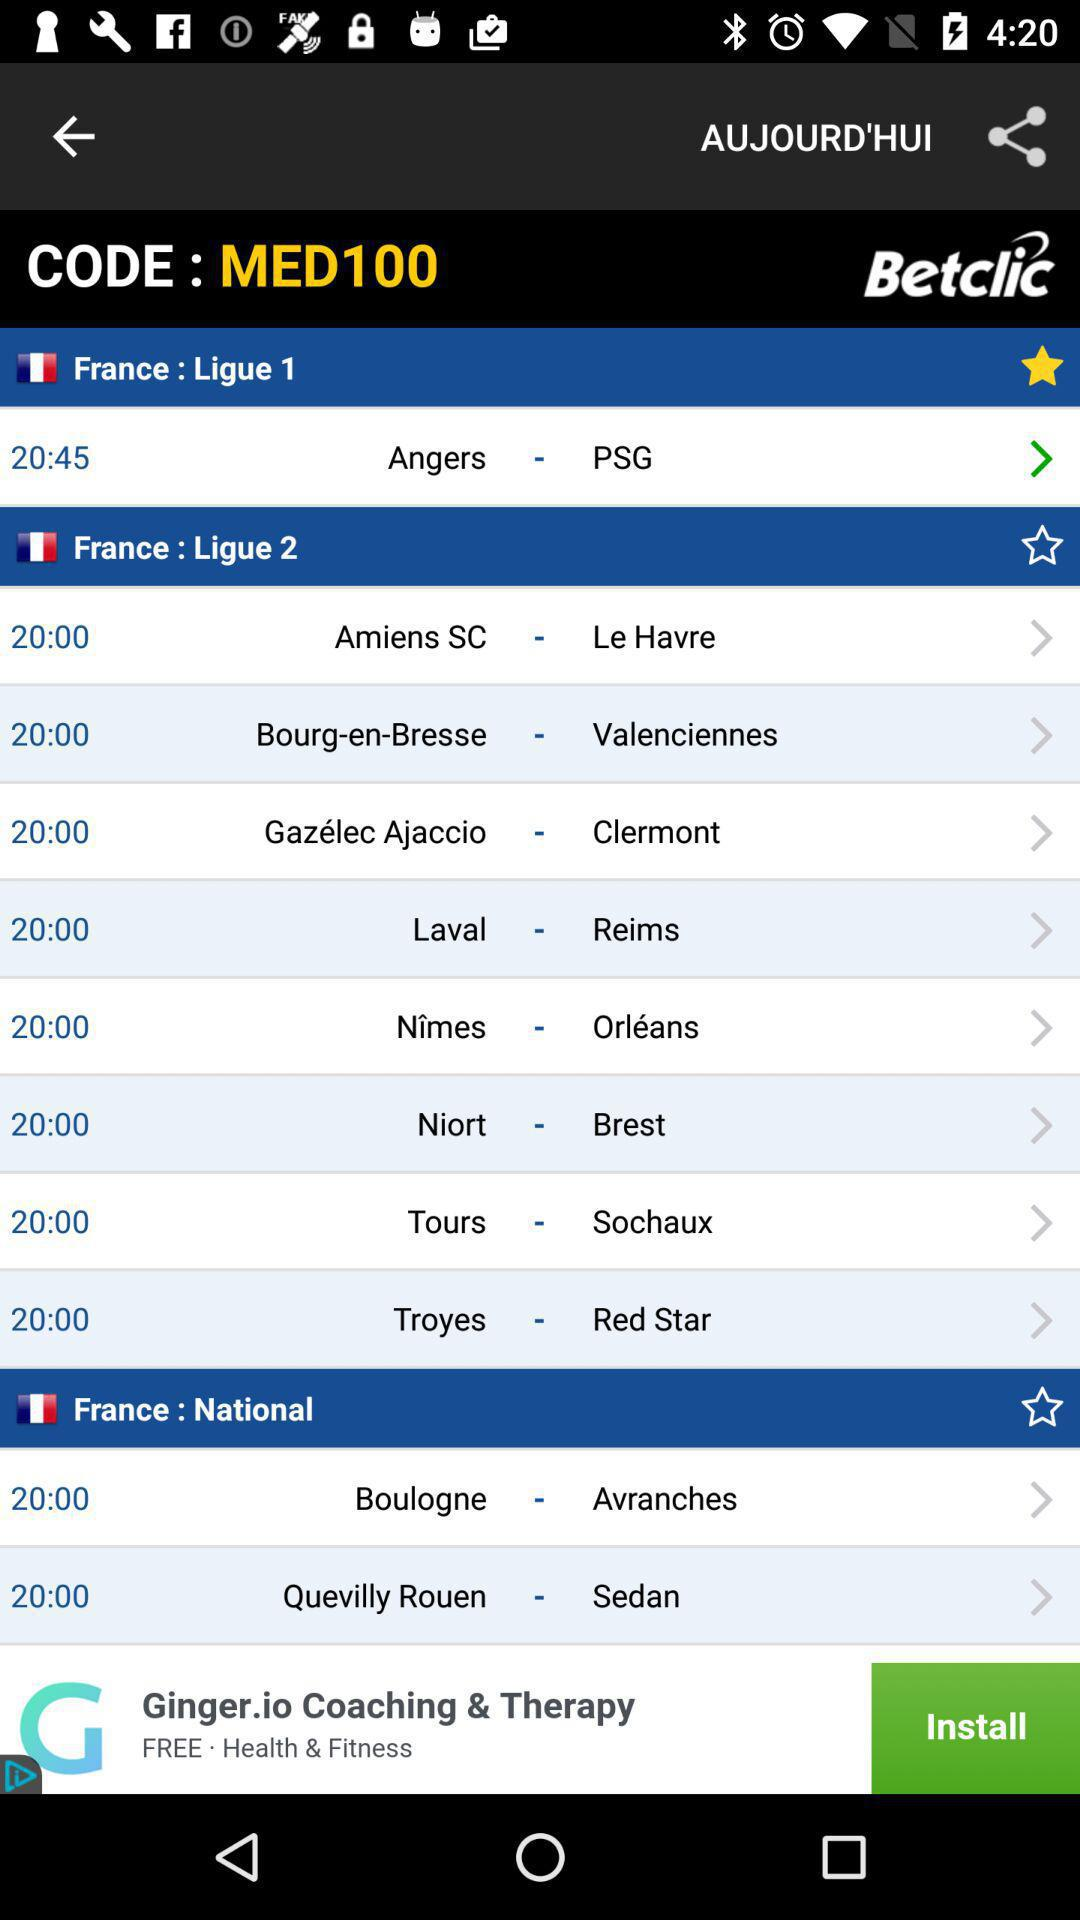What is the given code? The code is "MED100". 